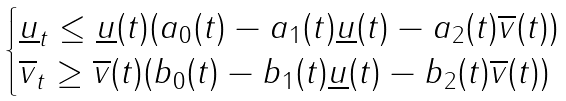<formula> <loc_0><loc_0><loc_500><loc_500>\begin{cases} \underline { u } _ { t } \leq \underline { u } ( t ) ( a _ { 0 } ( t ) - a _ { 1 } ( t ) \underline { u } ( t ) - a _ { 2 } ( t ) \overline { v } ( t ) ) \\ \overline { v } _ { t } \geq \overline { v } ( t ) ( b _ { 0 } ( t ) - b _ { 1 } ( t ) \underline { u } ( t ) - b _ { 2 } ( t ) \overline { v } ( t ) ) \\ \end{cases}</formula> 